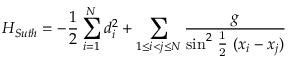<formula> <loc_0><loc_0><loc_500><loc_500>H _ { S u t h } = - \frac { 1 } { 2 } \sum _ { i = 1 } ^ { N } d _ { i } ^ { 2 } + \sum _ { 1 \leq i < j \leq N } \frac { g } { { \sin } ^ { 2 } \frac { 1 } { 2 } ( x _ { i } - x _ { j } ) }</formula> 